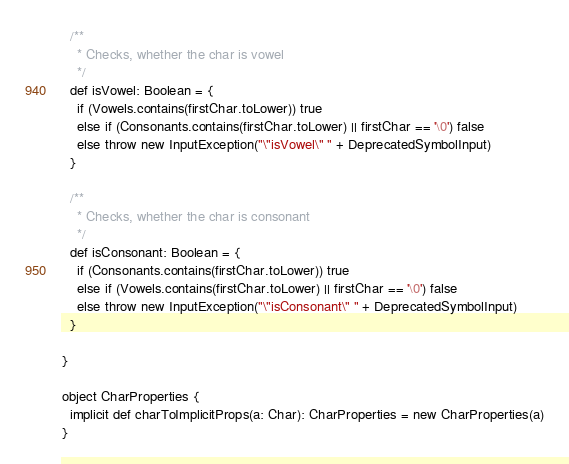Convert code to text. <code><loc_0><loc_0><loc_500><loc_500><_Scala_>
  /**
    * Checks, whether the char is vowel
    */
  def isVowel: Boolean = {
    if (Vowels.contains(firstChar.toLower)) true
    else if (Consonants.contains(firstChar.toLower) || firstChar == '\0') false
    else throw new InputException("\"isVowel\" " + DeprecatedSymbolInput)
  }

  /**
    * Checks, whether the char is consonant
    */
  def isConsonant: Boolean = {
    if (Consonants.contains(firstChar.toLower)) true
    else if (Vowels.contains(firstChar.toLower) || firstChar == '\0') false
    else throw new InputException("\"isConsonant\" " + DeprecatedSymbolInput)
  }

}

object CharProperties {
  implicit def charToImplicitProps(a: Char): CharProperties = new CharProperties(a)
}
</code> 